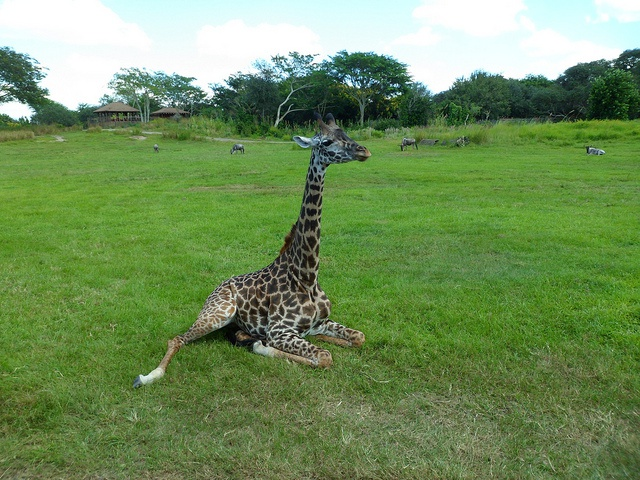Describe the objects in this image and their specific colors. I can see a giraffe in lightblue, black, gray, darkgray, and darkgreen tones in this image. 